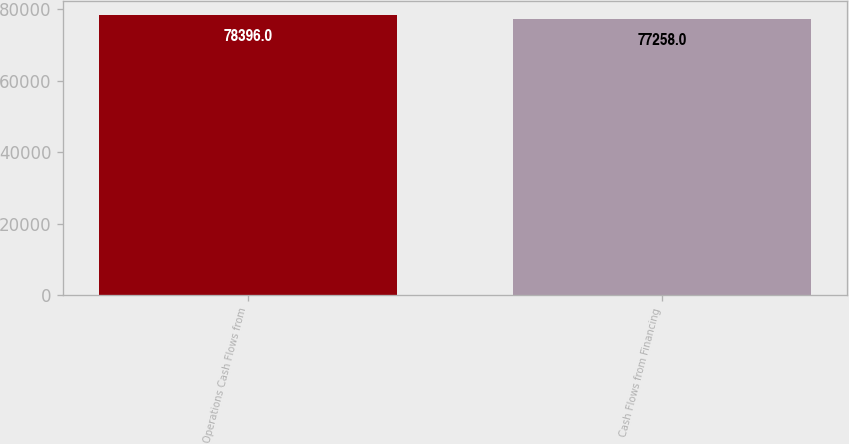Convert chart to OTSL. <chart><loc_0><loc_0><loc_500><loc_500><bar_chart><fcel>Operations Cash Flows from<fcel>Cash Flows from Financing<nl><fcel>78396<fcel>77258<nl></chart> 